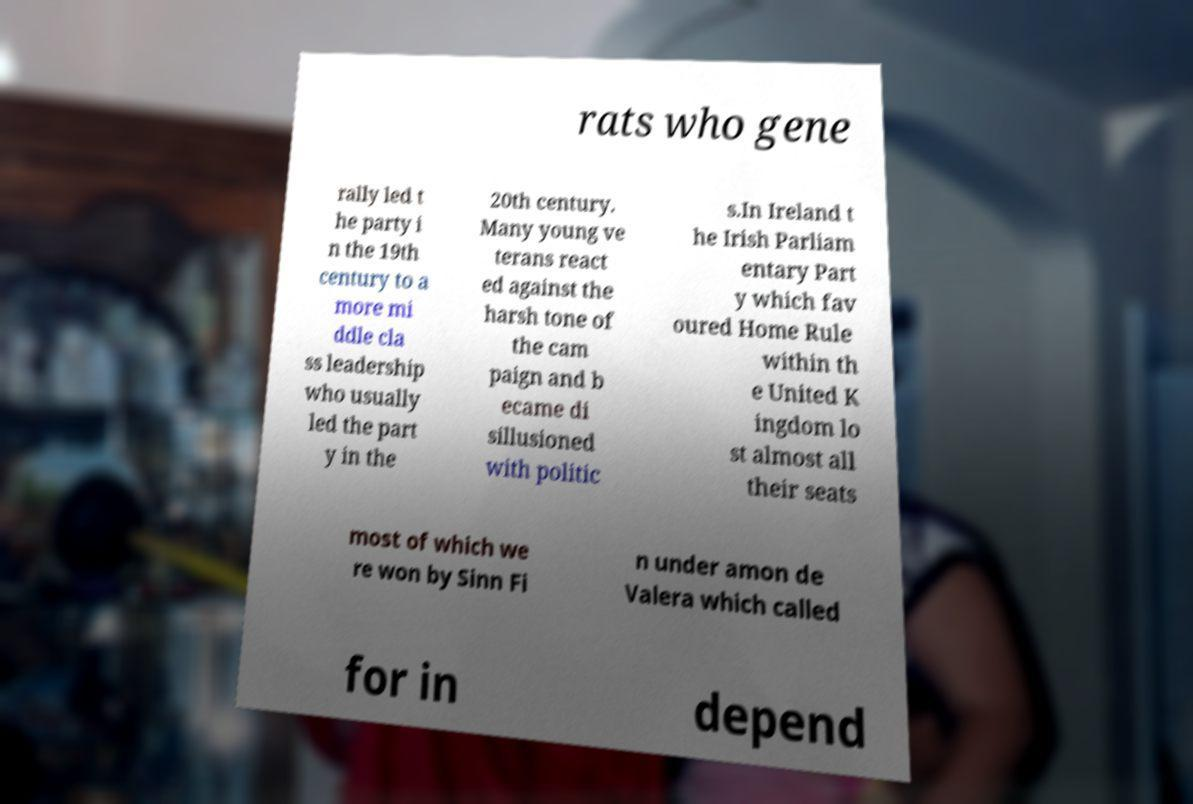Can you accurately transcribe the text from the provided image for me? rats who gene rally led t he party i n the 19th century to a more mi ddle cla ss leadership who usually led the part y in the 20th century. Many young ve terans react ed against the harsh tone of the cam paign and b ecame di sillusioned with politic s.In Ireland t he Irish Parliam entary Part y which fav oured Home Rule within th e United K ingdom lo st almost all their seats most of which we re won by Sinn Fi n under amon de Valera which called for in depend 